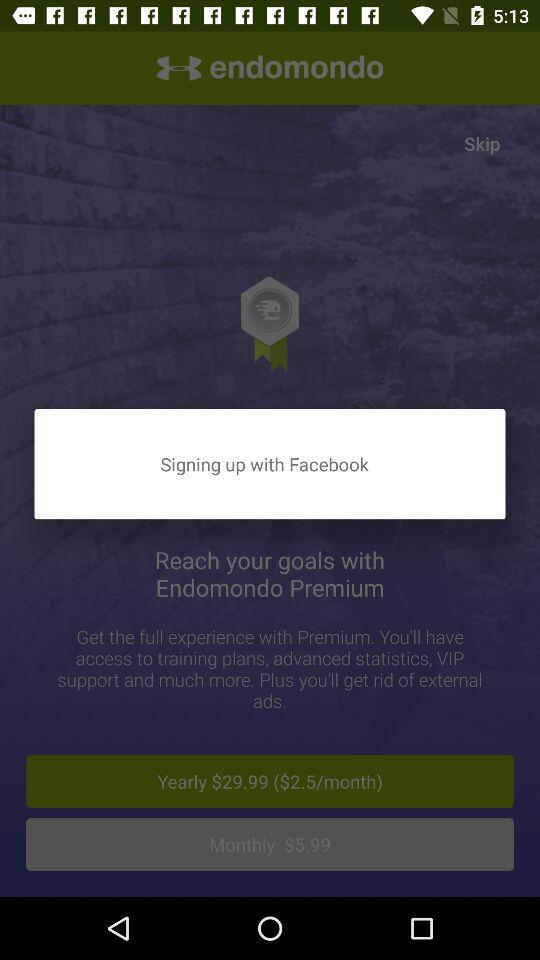Through what application can we sign up? You can sign up with "Facebook". 